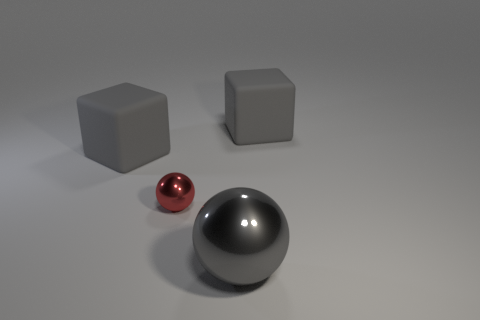Add 2 large purple shiny spheres. How many objects exist? 6 Add 2 gray matte things. How many gray matte things are left? 4 Add 1 small green spheres. How many small green spheres exist? 1 Subtract 0 purple spheres. How many objects are left? 4 Subtract all tiny red things. Subtract all cubes. How many objects are left? 1 